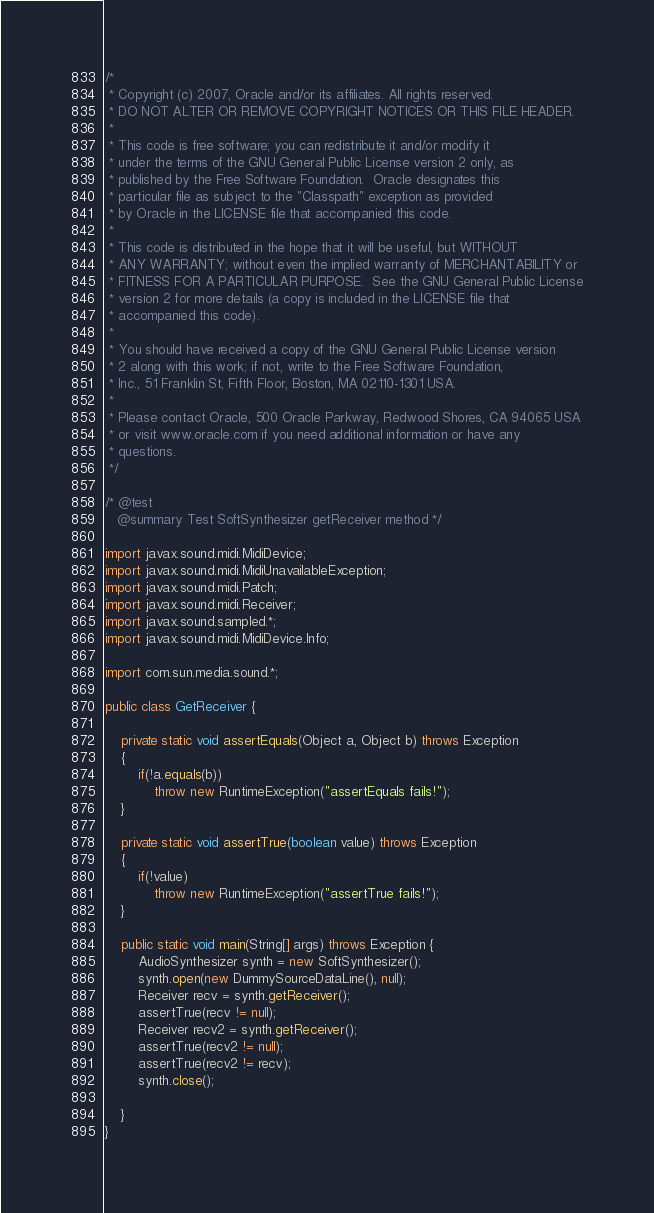<code> <loc_0><loc_0><loc_500><loc_500><_Java_>/*
 * Copyright (c) 2007, Oracle and/or its affiliates. All rights reserved.
 * DO NOT ALTER OR REMOVE COPYRIGHT NOTICES OR THIS FILE HEADER.
 *
 * This code is free software; you can redistribute it and/or modify it
 * under the terms of the GNU General Public License version 2 only, as
 * published by the Free Software Foundation.  Oracle designates this
 * particular file as subject to the "Classpath" exception as provided
 * by Oracle in the LICENSE file that accompanied this code.
 *
 * This code is distributed in the hope that it will be useful, but WITHOUT
 * ANY WARRANTY; without even the implied warranty of MERCHANTABILITY or
 * FITNESS FOR A PARTICULAR PURPOSE.  See the GNU General Public License
 * version 2 for more details (a copy is included in the LICENSE file that
 * accompanied this code).
 *
 * You should have received a copy of the GNU General Public License version
 * 2 along with this work; if not, write to the Free Software Foundation,
 * Inc., 51 Franklin St, Fifth Floor, Boston, MA 02110-1301 USA.
 *
 * Please contact Oracle, 500 Oracle Parkway, Redwood Shores, CA 94065 USA
 * or visit www.oracle.com if you need additional information or have any
 * questions.
 */

/* @test
   @summary Test SoftSynthesizer getReceiver method */

import javax.sound.midi.MidiDevice;
import javax.sound.midi.MidiUnavailableException;
import javax.sound.midi.Patch;
import javax.sound.midi.Receiver;
import javax.sound.sampled.*;
import javax.sound.midi.MidiDevice.Info;

import com.sun.media.sound.*;

public class GetReceiver {

    private static void assertEquals(Object a, Object b) throws Exception
    {
        if(!a.equals(b))
            throw new RuntimeException("assertEquals fails!");
    }

    private static void assertTrue(boolean value) throws Exception
    {
        if(!value)
            throw new RuntimeException("assertTrue fails!");
    }

    public static void main(String[] args) throws Exception {
        AudioSynthesizer synth = new SoftSynthesizer();
        synth.open(new DummySourceDataLine(), null);
        Receiver recv = synth.getReceiver();
        assertTrue(recv != null);
        Receiver recv2 = synth.getReceiver();
        assertTrue(recv2 != null);
        assertTrue(recv2 != recv);
        synth.close();

    }
}
</code> 